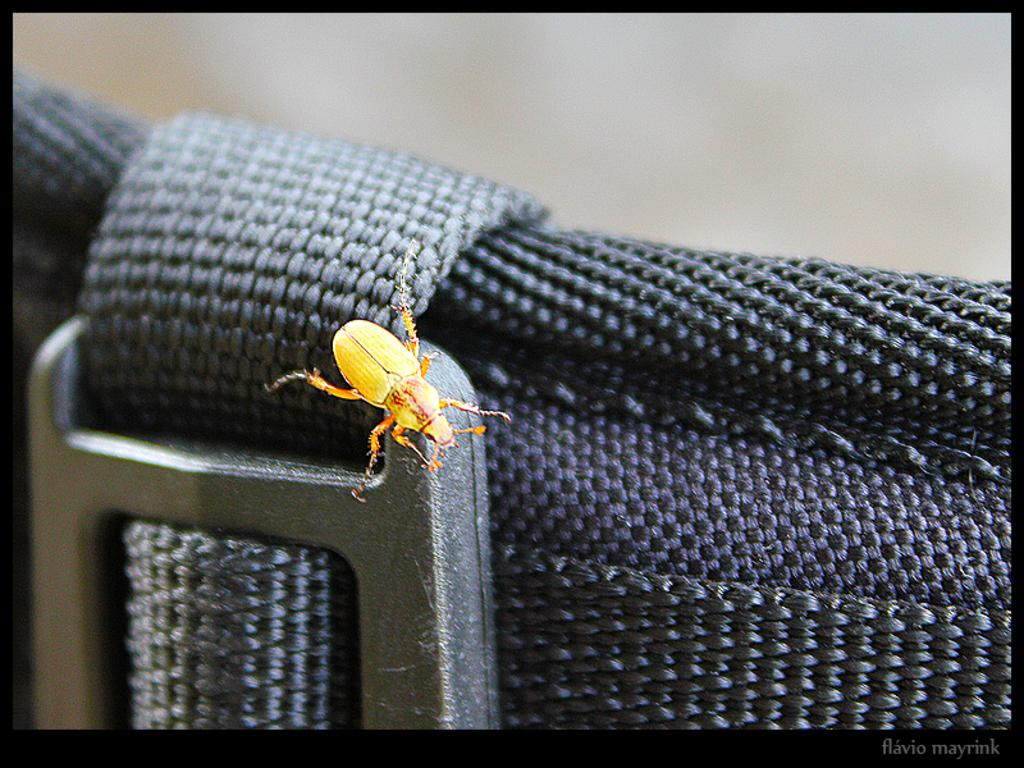What type of creature can be seen in the image? There is an insect in the image. Where is the insect located? The insect is on a chair. How many apples are being controlled by the insect in the image? There are no apples present in the image, and the insect is not controlling anything. 